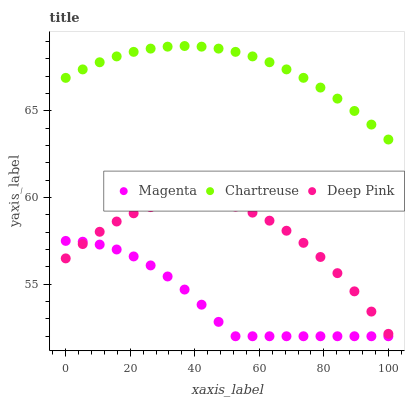Does Magenta have the minimum area under the curve?
Answer yes or no. Yes. Does Chartreuse have the maximum area under the curve?
Answer yes or no. Yes. Does Deep Pink have the minimum area under the curve?
Answer yes or no. No. Does Deep Pink have the maximum area under the curve?
Answer yes or no. No. Is Chartreuse the smoothest?
Answer yes or no. Yes. Is Deep Pink the roughest?
Answer yes or no. Yes. Is Deep Pink the smoothest?
Answer yes or no. No. Is Chartreuse the roughest?
Answer yes or no. No. Does Magenta have the lowest value?
Answer yes or no. Yes. Does Deep Pink have the lowest value?
Answer yes or no. No. Does Chartreuse have the highest value?
Answer yes or no. Yes. Does Deep Pink have the highest value?
Answer yes or no. No. Is Deep Pink less than Chartreuse?
Answer yes or no. Yes. Is Chartreuse greater than Deep Pink?
Answer yes or no. Yes. Does Deep Pink intersect Magenta?
Answer yes or no. Yes. Is Deep Pink less than Magenta?
Answer yes or no. No. Is Deep Pink greater than Magenta?
Answer yes or no. No. Does Deep Pink intersect Chartreuse?
Answer yes or no. No. 